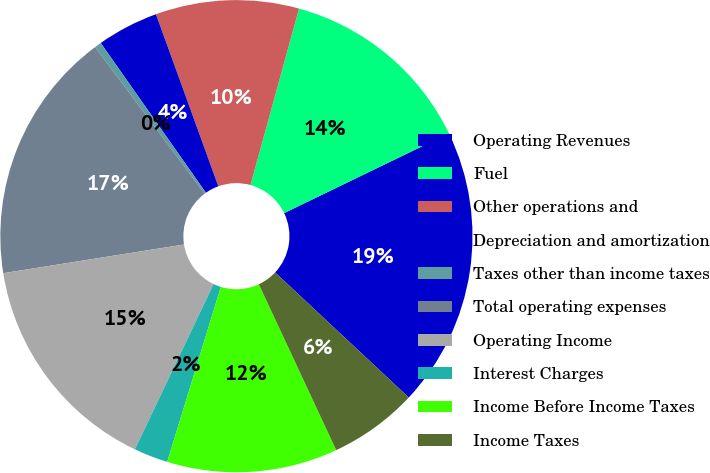Convert chart to OTSL. <chart><loc_0><loc_0><loc_500><loc_500><pie_chart><fcel>Operating Revenues<fcel>Fuel<fcel>Other operations and<fcel>Depreciation and amortization<fcel>Taxes other than income taxes<fcel>Total operating expenses<fcel>Operating Income<fcel>Interest Charges<fcel>Income Before Income Taxes<fcel>Income Taxes<nl><fcel>19.15%<fcel>13.55%<fcel>9.81%<fcel>4.21%<fcel>0.47%<fcel>17.29%<fcel>15.42%<fcel>2.34%<fcel>11.68%<fcel>6.08%<nl></chart> 